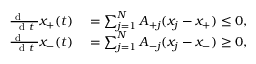<formula> <loc_0><loc_0><loc_500><loc_500>\begin{array} { r l } { \frac { d \, } { d t } x _ { + } ( t ) } & = \sum _ { j = 1 } ^ { N } A _ { + j } ( x _ { j } - x _ { + } ) \leq 0 , } \\ { \frac { d \, } { d t } x _ { - } ( t ) } & = \sum _ { j = 1 } ^ { N } A _ { - j } ( x _ { j } - x _ { - } ) \geq 0 , } \end{array}</formula> 